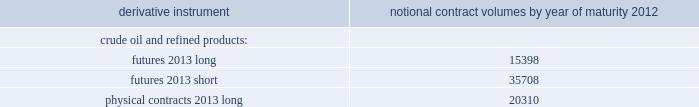Table of contents valero energy corporation and subsidiaries notes to consolidated financial statements ( continued ) commodity price risk we are exposed to market risks related to the volatility in the price of crude oil , refined products ( primarily gasoline and distillate ) , grain ( primarily corn ) , and natural gas used in our operations .
To reduce the impact of price volatility on our results of operations and cash flows , we use commodity derivative instruments , including futures , swaps , and options .
We use the futures markets for the available liquidity , which provides greater flexibility in transacting our hedging and trading operations .
We use swaps primarily to manage our price exposure .
Our positions in commodity derivative instruments are monitored and managed on a daily basis by a risk control group to ensure compliance with our stated risk management policy that has been approved by our board of directors .
For risk management purposes , we use fair value hedges , cash flow hedges , and economic hedges .
In addition to the use of derivative instruments to manage commodity price risk , we also enter into certain commodity derivative instruments for trading purposes .
Our objective for entering into each type of hedge or trading derivative is described below .
Fair value hedges fair value hedges are used to hedge price volatility in certain refining inventories and firm commitments to purchase inventories .
The level of activity for our fair value hedges is based on the level of our operating inventories , and generally represents the amount by which our inventories differ from our previous year-end lifo inventory levels .
As of december 31 , 2011 , we had the following outstanding commodity derivative instruments that were entered into to hedge crude oil and refined product inventories and commodity derivative instruments related to the physical purchase of crude oil and refined products at a fixed price .
The information presents the notional volume of outstanding contracts by type of instrument and year of maturity ( volumes in thousands of barrels ) .
Notional contract volumes by year of maturity derivative instrument 2012 .

How many total derivative instruments matured by 2012? 
Computations: ((15398 + 35708) + 20310)
Answer: 71416.0. 